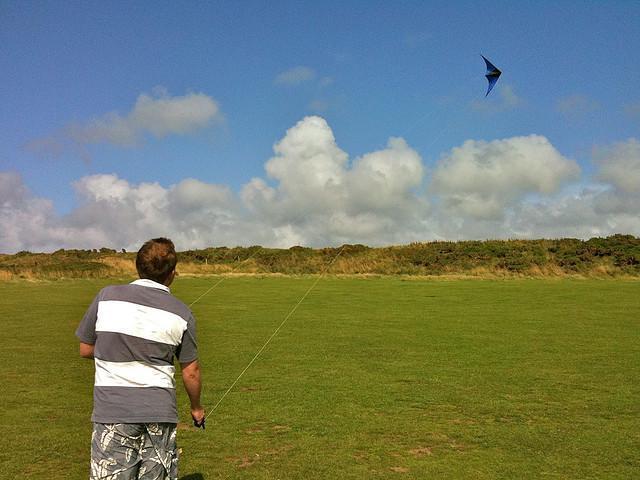How many black dogs are there?
Give a very brief answer. 0. 